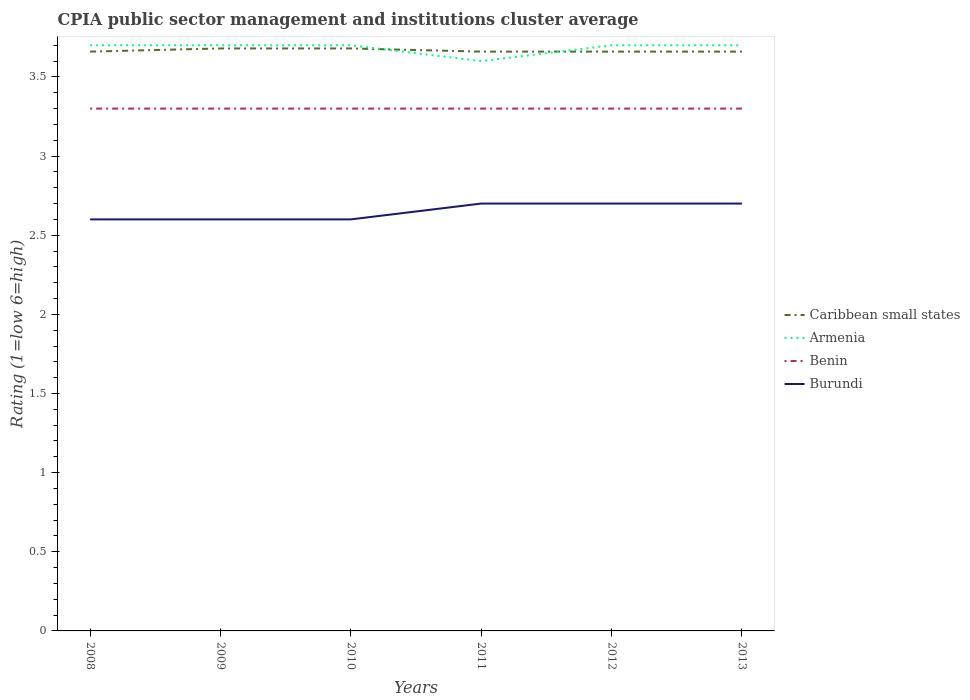How many different coloured lines are there?
Give a very brief answer. 4. Does the line corresponding to Armenia intersect with the line corresponding to Burundi?
Keep it short and to the point. No. What is the total CPIA rating in Armenia in the graph?
Offer a very short reply. 0. What is the difference between the highest and the second highest CPIA rating in Armenia?
Your response must be concise. 0.1. How many years are there in the graph?
Keep it short and to the point. 6. Are the values on the major ticks of Y-axis written in scientific E-notation?
Your answer should be compact. No. Does the graph contain any zero values?
Offer a terse response. No. Does the graph contain grids?
Provide a short and direct response. No. How are the legend labels stacked?
Make the answer very short. Vertical. What is the title of the graph?
Your response must be concise. CPIA public sector management and institutions cluster average. Does "Eritrea" appear as one of the legend labels in the graph?
Keep it short and to the point. No. What is the label or title of the X-axis?
Give a very brief answer. Years. What is the Rating (1=low 6=high) in Caribbean small states in 2008?
Your answer should be compact. 3.66. What is the Rating (1=low 6=high) of Burundi in 2008?
Make the answer very short. 2.6. What is the Rating (1=low 6=high) of Caribbean small states in 2009?
Your answer should be compact. 3.68. What is the Rating (1=low 6=high) in Benin in 2009?
Your response must be concise. 3.3. What is the Rating (1=low 6=high) in Burundi in 2009?
Offer a very short reply. 2.6. What is the Rating (1=low 6=high) in Caribbean small states in 2010?
Your answer should be compact. 3.68. What is the Rating (1=low 6=high) of Benin in 2010?
Keep it short and to the point. 3.3. What is the Rating (1=low 6=high) in Caribbean small states in 2011?
Your answer should be compact. 3.66. What is the Rating (1=low 6=high) of Armenia in 2011?
Give a very brief answer. 3.6. What is the Rating (1=low 6=high) in Benin in 2011?
Make the answer very short. 3.3. What is the Rating (1=low 6=high) of Caribbean small states in 2012?
Keep it short and to the point. 3.66. What is the Rating (1=low 6=high) in Armenia in 2012?
Provide a succinct answer. 3.7. What is the Rating (1=low 6=high) in Caribbean small states in 2013?
Make the answer very short. 3.66. What is the Rating (1=low 6=high) in Armenia in 2013?
Make the answer very short. 3.7. What is the Rating (1=low 6=high) in Benin in 2013?
Ensure brevity in your answer.  3.3. Across all years, what is the maximum Rating (1=low 6=high) of Caribbean small states?
Make the answer very short. 3.68. Across all years, what is the maximum Rating (1=low 6=high) of Benin?
Keep it short and to the point. 3.3. Across all years, what is the minimum Rating (1=low 6=high) of Caribbean small states?
Your response must be concise. 3.66. Across all years, what is the minimum Rating (1=low 6=high) in Armenia?
Give a very brief answer. 3.6. Across all years, what is the minimum Rating (1=low 6=high) in Benin?
Your answer should be compact. 3.3. Across all years, what is the minimum Rating (1=low 6=high) in Burundi?
Give a very brief answer. 2.6. What is the total Rating (1=low 6=high) in Caribbean small states in the graph?
Your answer should be very brief. 22. What is the total Rating (1=low 6=high) in Armenia in the graph?
Keep it short and to the point. 22.1. What is the total Rating (1=low 6=high) in Benin in the graph?
Offer a terse response. 19.8. What is the total Rating (1=low 6=high) in Burundi in the graph?
Offer a very short reply. 15.9. What is the difference between the Rating (1=low 6=high) in Caribbean small states in 2008 and that in 2009?
Provide a short and direct response. -0.02. What is the difference between the Rating (1=low 6=high) of Armenia in 2008 and that in 2009?
Give a very brief answer. 0. What is the difference between the Rating (1=low 6=high) in Benin in 2008 and that in 2009?
Make the answer very short. 0. What is the difference between the Rating (1=low 6=high) in Burundi in 2008 and that in 2009?
Provide a succinct answer. 0. What is the difference between the Rating (1=low 6=high) of Caribbean small states in 2008 and that in 2010?
Provide a succinct answer. -0.02. What is the difference between the Rating (1=low 6=high) of Armenia in 2008 and that in 2010?
Give a very brief answer. 0. What is the difference between the Rating (1=low 6=high) in Caribbean small states in 2008 and that in 2012?
Your answer should be very brief. 0. What is the difference between the Rating (1=low 6=high) in Armenia in 2008 and that in 2012?
Make the answer very short. 0. What is the difference between the Rating (1=low 6=high) of Benin in 2008 and that in 2012?
Your answer should be very brief. 0. What is the difference between the Rating (1=low 6=high) of Caribbean small states in 2008 and that in 2013?
Your response must be concise. 0. What is the difference between the Rating (1=low 6=high) of Armenia in 2008 and that in 2013?
Keep it short and to the point. 0. What is the difference between the Rating (1=low 6=high) in Burundi in 2008 and that in 2013?
Give a very brief answer. -0.1. What is the difference between the Rating (1=low 6=high) in Burundi in 2009 and that in 2010?
Your answer should be compact. 0. What is the difference between the Rating (1=low 6=high) in Benin in 2009 and that in 2011?
Your response must be concise. 0. What is the difference between the Rating (1=low 6=high) in Burundi in 2009 and that in 2011?
Offer a terse response. -0.1. What is the difference between the Rating (1=low 6=high) of Armenia in 2009 and that in 2012?
Keep it short and to the point. 0. What is the difference between the Rating (1=low 6=high) of Burundi in 2009 and that in 2012?
Your answer should be very brief. -0.1. What is the difference between the Rating (1=low 6=high) in Caribbean small states in 2009 and that in 2013?
Offer a very short reply. 0.02. What is the difference between the Rating (1=low 6=high) of Benin in 2009 and that in 2013?
Your answer should be very brief. 0. What is the difference between the Rating (1=low 6=high) of Caribbean small states in 2010 and that in 2011?
Provide a short and direct response. 0.02. What is the difference between the Rating (1=low 6=high) in Benin in 2010 and that in 2011?
Offer a very short reply. 0. What is the difference between the Rating (1=low 6=high) in Burundi in 2010 and that in 2011?
Give a very brief answer. -0.1. What is the difference between the Rating (1=low 6=high) of Benin in 2010 and that in 2012?
Ensure brevity in your answer.  0. What is the difference between the Rating (1=low 6=high) in Caribbean small states in 2010 and that in 2013?
Your answer should be compact. 0.02. What is the difference between the Rating (1=low 6=high) in Armenia in 2010 and that in 2013?
Keep it short and to the point. 0. What is the difference between the Rating (1=low 6=high) in Burundi in 2010 and that in 2013?
Offer a terse response. -0.1. What is the difference between the Rating (1=low 6=high) of Caribbean small states in 2011 and that in 2012?
Offer a terse response. 0. What is the difference between the Rating (1=low 6=high) of Armenia in 2011 and that in 2012?
Offer a terse response. -0.1. What is the difference between the Rating (1=low 6=high) of Benin in 2011 and that in 2012?
Your answer should be compact. 0. What is the difference between the Rating (1=low 6=high) in Caribbean small states in 2011 and that in 2013?
Offer a very short reply. 0. What is the difference between the Rating (1=low 6=high) in Armenia in 2011 and that in 2013?
Your answer should be compact. -0.1. What is the difference between the Rating (1=low 6=high) of Benin in 2011 and that in 2013?
Your answer should be very brief. 0. What is the difference between the Rating (1=low 6=high) of Burundi in 2011 and that in 2013?
Offer a terse response. 0. What is the difference between the Rating (1=low 6=high) of Burundi in 2012 and that in 2013?
Make the answer very short. 0. What is the difference between the Rating (1=low 6=high) of Caribbean small states in 2008 and the Rating (1=low 6=high) of Armenia in 2009?
Offer a very short reply. -0.04. What is the difference between the Rating (1=low 6=high) in Caribbean small states in 2008 and the Rating (1=low 6=high) in Benin in 2009?
Offer a very short reply. 0.36. What is the difference between the Rating (1=low 6=high) of Caribbean small states in 2008 and the Rating (1=low 6=high) of Burundi in 2009?
Keep it short and to the point. 1.06. What is the difference between the Rating (1=low 6=high) of Armenia in 2008 and the Rating (1=low 6=high) of Benin in 2009?
Your answer should be compact. 0.4. What is the difference between the Rating (1=low 6=high) of Armenia in 2008 and the Rating (1=low 6=high) of Burundi in 2009?
Offer a terse response. 1.1. What is the difference between the Rating (1=low 6=high) in Caribbean small states in 2008 and the Rating (1=low 6=high) in Armenia in 2010?
Your answer should be compact. -0.04. What is the difference between the Rating (1=low 6=high) in Caribbean small states in 2008 and the Rating (1=low 6=high) in Benin in 2010?
Your answer should be very brief. 0.36. What is the difference between the Rating (1=low 6=high) in Caribbean small states in 2008 and the Rating (1=low 6=high) in Burundi in 2010?
Provide a short and direct response. 1.06. What is the difference between the Rating (1=low 6=high) of Armenia in 2008 and the Rating (1=low 6=high) of Burundi in 2010?
Provide a short and direct response. 1.1. What is the difference between the Rating (1=low 6=high) of Benin in 2008 and the Rating (1=low 6=high) of Burundi in 2010?
Offer a terse response. 0.7. What is the difference between the Rating (1=low 6=high) of Caribbean small states in 2008 and the Rating (1=low 6=high) of Benin in 2011?
Give a very brief answer. 0.36. What is the difference between the Rating (1=low 6=high) of Armenia in 2008 and the Rating (1=low 6=high) of Benin in 2011?
Give a very brief answer. 0.4. What is the difference between the Rating (1=low 6=high) of Armenia in 2008 and the Rating (1=low 6=high) of Burundi in 2011?
Your response must be concise. 1. What is the difference between the Rating (1=low 6=high) of Benin in 2008 and the Rating (1=low 6=high) of Burundi in 2011?
Ensure brevity in your answer.  0.6. What is the difference between the Rating (1=low 6=high) of Caribbean small states in 2008 and the Rating (1=low 6=high) of Armenia in 2012?
Provide a succinct answer. -0.04. What is the difference between the Rating (1=low 6=high) of Caribbean small states in 2008 and the Rating (1=low 6=high) of Benin in 2012?
Give a very brief answer. 0.36. What is the difference between the Rating (1=low 6=high) of Benin in 2008 and the Rating (1=low 6=high) of Burundi in 2012?
Offer a very short reply. 0.6. What is the difference between the Rating (1=low 6=high) in Caribbean small states in 2008 and the Rating (1=low 6=high) in Armenia in 2013?
Make the answer very short. -0.04. What is the difference between the Rating (1=low 6=high) in Caribbean small states in 2008 and the Rating (1=low 6=high) in Benin in 2013?
Provide a succinct answer. 0.36. What is the difference between the Rating (1=low 6=high) of Armenia in 2008 and the Rating (1=low 6=high) of Benin in 2013?
Offer a terse response. 0.4. What is the difference between the Rating (1=low 6=high) in Armenia in 2008 and the Rating (1=low 6=high) in Burundi in 2013?
Offer a very short reply. 1. What is the difference between the Rating (1=low 6=high) of Caribbean small states in 2009 and the Rating (1=low 6=high) of Armenia in 2010?
Offer a terse response. -0.02. What is the difference between the Rating (1=low 6=high) of Caribbean small states in 2009 and the Rating (1=low 6=high) of Benin in 2010?
Keep it short and to the point. 0.38. What is the difference between the Rating (1=low 6=high) in Caribbean small states in 2009 and the Rating (1=low 6=high) in Burundi in 2010?
Give a very brief answer. 1.08. What is the difference between the Rating (1=low 6=high) of Armenia in 2009 and the Rating (1=low 6=high) of Benin in 2010?
Keep it short and to the point. 0.4. What is the difference between the Rating (1=low 6=high) in Armenia in 2009 and the Rating (1=low 6=high) in Burundi in 2010?
Make the answer very short. 1.1. What is the difference between the Rating (1=low 6=high) of Benin in 2009 and the Rating (1=low 6=high) of Burundi in 2010?
Ensure brevity in your answer.  0.7. What is the difference between the Rating (1=low 6=high) of Caribbean small states in 2009 and the Rating (1=low 6=high) of Benin in 2011?
Provide a succinct answer. 0.38. What is the difference between the Rating (1=low 6=high) of Caribbean small states in 2009 and the Rating (1=low 6=high) of Burundi in 2011?
Provide a short and direct response. 0.98. What is the difference between the Rating (1=low 6=high) of Armenia in 2009 and the Rating (1=low 6=high) of Benin in 2011?
Offer a very short reply. 0.4. What is the difference between the Rating (1=low 6=high) in Armenia in 2009 and the Rating (1=low 6=high) in Burundi in 2011?
Offer a terse response. 1. What is the difference between the Rating (1=low 6=high) of Caribbean small states in 2009 and the Rating (1=low 6=high) of Armenia in 2012?
Provide a succinct answer. -0.02. What is the difference between the Rating (1=low 6=high) in Caribbean small states in 2009 and the Rating (1=low 6=high) in Benin in 2012?
Keep it short and to the point. 0.38. What is the difference between the Rating (1=low 6=high) in Armenia in 2009 and the Rating (1=low 6=high) in Benin in 2012?
Ensure brevity in your answer.  0.4. What is the difference between the Rating (1=low 6=high) of Armenia in 2009 and the Rating (1=low 6=high) of Burundi in 2012?
Provide a succinct answer. 1. What is the difference between the Rating (1=low 6=high) in Caribbean small states in 2009 and the Rating (1=low 6=high) in Armenia in 2013?
Provide a short and direct response. -0.02. What is the difference between the Rating (1=low 6=high) in Caribbean small states in 2009 and the Rating (1=low 6=high) in Benin in 2013?
Keep it short and to the point. 0.38. What is the difference between the Rating (1=low 6=high) in Caribbean small states in 2009 and the Rating (1=low 6=high) in Burundi in 2013?
Ensure brevity in your answer.  0.98. What is the difference between the Rating (1=low 6=high) of Armenia in 2009 and the Rating (1=low 6=high) of Burundi in 2013?
Provide a succinct answer. 1. What is the difference between the Rating (1=low 6=high) of Caribbean small states in 2010 and the Rating (1=low 6=high) of Armenia in 2011?
Offer a terse response. 0.08. What is the difference between the Rating (1=low 6=high) of Caribbean small states in 2010 and the Rating (1=low 6=high) of Benin in 2011?
Your response must be concise. 0.38. What is the difference between the Rating (1=low 6=high) in Caribbean small states in 2010 and the Rating (1=low 6=high) in Burundi in 2011?
Offer a terse response. 0.98. What is the difference between the Rating (1=low 6=high) in Benin in 2010 and the Rating (1=low 6=high) in Burundi in 2011?
Offer a very short reply. 0.6. What is the difference between the Rating (1=low 6=high) in Caribbean small states in 2010 and the Rating (1=low 6=high) in Armenia in 2012?
Your response must be concise. -0.02. What is the difference between the Rating (1=low 6=high) of Caribbean small states in 2010 and the Rating (1=low 6=high) of Benin in 2012?
Provide a succinct answer. 0.38. What is the difference between the Rating (1=low 6=high) of Armenia in 2010 and the Rating (1=low 6=high) of Burundi in 2012?
Your response must be concise. 1. What is the difference between the Rating (1=low 6=high) of Benin in 2010 and the Rating (1=low 6=high) of Burundi in 2012?
Ensure brevity in your answer.  0.6. What is the difference between the Rating (1=low 6=high) in Caribbean small states in 2010 and the Rating (1=low 6=high) in Armenia in 2013?
Give a very brief answer. -0.02. What is the difference between the Rating (1=low 6=high) in Caribbean small states in 2010 and the Rating (1=low 6=high) in Benin in 2013?
Offer a very short reply. 0.38. What is the difference between the Rating (1=low 6=high) in Caribbean small states in 2010 and the Rating (1=low 6=high) in Burundi in 2013?
Your answer should be very brief. 0.98. What is the difference between the Rating (1=low 6=high) in Caribbean small states in 2011 and the Rating (1=low 6=high) in Armenia in 2012?
Offer a terse response. -0.04. What is the difference between the Rating (1=low 6=high) of Caribbean small states in 2011 and the Rating (1=low 6=high) of Benin in 2012?
Ensure brevity in your answer.  0.36. What is the difference between the Rating (1=low 6=high) of Caribbean small states in 2011 and the Rating (1=low 6=high) of Burundi in 2012?
Keep it short and to the point. 0.96. What is the difference between the Rating (1=low 6=high) in Armenia in 2011 and the Rating (1=low 6=high) in Burundi in 2012?
Give a very brief answer. 0.9. What is the difference between the Rating (1=low 6=high) of Caribbean small states in 2011 and the Rating (1=low 6=high) of Armenia in 2013?
Your answer should be compact. -0.04. What is the difference between the Rating (1=low 6=high) of Caribbean small states in 2011 and the Rating (1=low 6=high) of Benin in 2013?
Your answer should be very brief. 0.36. What is the difference between the Rating (1=low 6=high) in Caribbean small states in 2011 and the Rating (1=low 6=high) in Burundi in 2013?
Your answer should be very brief. 0.96. What is the difference between the Rating (1=low 6=high) of Caribbean small states in 2012 and the Rating (1=low 6=high) of Armenia in 2013?
Ensure brevity in your answer.  -0.04. What is the difference between the Rating (1=low 6=high) in Caribbean small states in 2012 and the Rating (1=low 6=high) in Benin in 2013?
Your response must be concise. 0.36. What is the difference between the Rating (1=low 6=high) of Caribbean small states in 2012 and the Rating (1=low 6=high) of Burundi in 2013?
Make the answer very short. 0.96. What is the difference between the Rating (1=low 6=high) of Armenia in 2012 and the Rating (1=low 6=high) of Benin in 2013?
Give a very brief answer. 0.4. What is the difference between the Rating (1=low 6=high) in Armenia in 2012 and the Rating (1=low 6=high) in Burundi in 2013?
Provide a succinct answer. 1. What is the difference between the Rating (1=low 6=high) of Benin in 2012 and the Rating (1=low 6=high) of Burundi in 2013?
Your response must be concise. 0.6. What is the average Rating (1=low 6=high) of Caribbean small states per year?
Your answer should be very brief. 3.67. What is the average Rating (1=low 6=high) of Armenia per year?
Ensure brevity in your answer.  3.68. What is the average Rating (1=low 6=high) of Burundi per year?
Give a very brief answer. 2.65. In the year 2008, what is the difference between the Rating (1=low 6=high) of Caribbean small states and Rating (1=low 6=high) of Armenia?
Offer a terse response. -0.04. In the year 2008, what is the difference between the Rating (1=low 6=high) in Caribbean small states and Rating (1=low 6=high) in Benin?
Make the answer very short. 0.36. In the year 2008, what is the difference between the Rating (1=low 6=high) of Caribbean small states and Rating (1=low 6=high) of Burundi?
Offer a terse response. 1.06. In the year 2008, what is the difference between the Rating (1=low 6=high) in Armenia and Rating (1=low 6=high) in Benin?
Your answer should be very brief. 0.4. In the year 2008, what is the difference between the Rating (1=low 6=high) in Armenia and Rating (1=low 6=high) in Burundi?
Your answer should be very brief. 1.1. In the year 2008, what is the difference between the Rating (1=low 6=high) of Benin and Rating (1=low 6=high) of Burundi?
Offer a very short reply. 0.7. In the year 2009, what is the difference between the Rating (1=low 6=high) in Caribbean small states and Rating (1=low 6=high) in Armenia?
Provide a succinct answer. -0.02. In the year 2009, what is the difference between the Rating (1=low 6=high) in Caribbean small states and Rating (1=low 6=high) in Benin?
Keep it short and to the point. 0.38. In the year 2009, what is the difference between the Rating (1=low 6=high) of Caribbean small states and Rating (1=low 6=high) of Burundi?
Keep it short and to the point. 1.08. In the year 2009, what is the difference between the Rating (1=low 6=high) in Armenia and Rating (1=low 6=high) in Benin?
Make the answer very short. 0.4. In the year 2010, what is the difference between the Rating (1=low 6=high) in Caribbean small states and Rating (1=low 6=high) in Armenia?
Keep it short and to the point. -0.02. In the year 2010, what is the difference between the Rating (1=low 6=high) in Caribbean small states and Rating (1=low 6=high) in Benin?
Offer a very short reply. 0.38. In the year 2010, what is the difference between the Rating (1=low 6=high) in Caribbean small states and Rating (1=low 6=high) in Burundi?
Offer a very short reply. 1.08. In the year 2010, what is the difference between the Rating (1=low 6=high) in Armenia and Rating (1=low 6=high) in Burundi?
Give a very brief answer. 1.1. In the year 2010, what is the difference between the Rating (1=low 6=high) of Benin and Rating (1=low 6=high) of Burundi?
Make the answer very short. 0.7. In the year 2011, what is the difference between the Rating (1=low 6=high) of Caribbean small states and Rating (1=low 6=high) of Armenia?
Your answer should be compact. 0.06. In the year 2011, what is the difference between the Rating (1=low 6=high) in Caribbean small states and Rating (1=low 6=high) in Benin?
Offer a terse response. 0.36. In the year 2011, what is the difference between the Rating (1=low 6=high) in Benin and Rating (1=low 6=high) in Burundi?
Your response must be concise. 0.6. In the year 2012, what is the difference between the Rating (1=low 6=high) in Caribbean small states and Rating (1=low 6=high) in Armenia?
Ensure brevity in your answer.  -0.04. In the year 2012, what is the difference between the Rating (1=low 6=high) of Caribbean small states and Rating (1=low 6=high) of Benin?
Your answer should be very brief. 0.36. In the year 2012, what is the difference between the Rating (1=low 6=high) in Armenia and Rating (1=low 6=high) in Benin?
Provide a succinct answer. 0.4. In the year 2012, what is the difference between the Rating (1=low 6=high) of Armenia and Rating (1=low 6=high) of Burundi?
Provide a short and direct response. 1. In the year 2012, what is the difference between the Rating (1=low 6=high) of Benin and Rating (1=low 6=high) of Burundi?
Offer a terse response. 0.6. In the year 2013, what is the difference between the Rating (1=low 6=high) of Caribbean small states and Rating (1=low 6=high) of Armenia?
Provide a succinct answer. -0.04. In the year 2013, what is the difference between the Rating (1=low 6=high) in Caribbean small states and Rating (1=low 6=high) in Benin?
Provide a short and direct response. 0.36. What is the ratio of the Rating (1=low 6=high) of Caribbean small states in 2008 to that in 2009?
Provide a succinct answer. 0.99. What is the ratio of the Rating (1=low 6=high) in Armenia in 2008 to that in 2009?
Ensure brevity in your answer.  1. What is the ratio of the Rating (1=low 6=high) in Benin in 2008 to that in 2009?
Your response must be concise. 1. What is the ratio of the Rating (1=low 6=high) of Caribbean small states in 2008 to that in 2010?
Provide a short and direct response. 0.99. What is the ratio of the Rating (1=low 6=high) in Armenia in 2008 to that in 2011?
Make the answer very short. 1.03. What is the ratio of the Rating (1=low 6=high) in Benin in 2008 to that in 2011?
Your answer should be compact. 1. What is the ratio of the Rating (1=low 6=high) in Burundi in 2008 to that in 2011?
Ensure brevity in your answer.  0.96. What is the ratio of the Rating (1=low 6=high) in Burundi in 2008 to that in 2012?
Your answer should be very brief. 0.96. What is the ratio of the Rating (1=low 6=high) of Caribbean small states in 2008 to that in 2013?
Offer a very short reply. 1. What is the ratio of the Rating (1=low 6=high) in Armenia in 2008 to that in 2013?
Your answer should be compact. 1. What is the ratio of the Rating (1=low 6=high) in Benin in 2008 to that in 2013?
Your response must be concise. 1. What is the ratio of the Rating (1=low 6=high) in Armenia in 2009 to that in 2010?
Your response must be concise. 1. What is the ratio of the Rating (1=low 6=high) in Benin in 2009 to that in 2010?
Offer a very short reply. 1. What is the ratio of the Rating (1=low 6=high) of Armenia in 2009 to that in 2011?
Give a very brief answer. 1.03. What is the ratio of the Rating (1=low 6=high) in Benin in 2009 to that in 2011?
Make the answer very short. 1. What is the ratio of the Rating (1=low 6=high) in Caribbean small states in 2009 to that in 2012?
Give a very brief answer. 1.01. What is the ratio of the Rating (1=low 6=high) of Armenia in 2009 to that in 2012?
Ensure brevity in your answer.  1. What is the ratio of the Rating (1=low 6=high) in Benin in 2009 to that in 2012?
Offer a terse response. 1. What is the ratio of the Rating (1=low 6=high) of Burundi in 2009 to that in 2012?
Ensure brevity in your answer.  0.96. What is the ratio of the Rating (1=low 6=high) of Caribbean small states in 2009 to that in 2013?
Ensure brevity in your answer.  1.01. What is the ratio of the Rating (1=low 6=high) of Armenia in 2009 to that in 2013?
Ensure brevity in your answer.  1. What is the ratio of the Rating (1=low 6=high) of Benin in 2009 to that in 2013?
Offer a very short reply. 1. What is the ratio of the Rating (1=low 6=high) of Caribbean small states in 2010 to that in 2011?
Offer a terse response. 1.01. What is the ratio of the Rating (1=low 6=high) of Armenia in 2010 to that in 2011?
Give a very brief answer. 1.03. What is the ratio of the Rating (1=low 6=high) of Caribbean small states in 2010 to that in 2012?
Keep it short and to the point. 1.01. What is the ratio of the Rating (1=low 6=high) in Benin in 2010 to that in 2012?
Your answer should be very brief. 1. What is the ratio of the Rating (1=low 6=high) in Burundi in 2010 to that in 2012?
Your answer should be compact. 0.96. What is the ratio of the Rating (1=low 6=high) of Caribbean small states in 2010 to that in 2013?
Ensure brevity in your answer.  1.01. What is the ratio of the Rating (1=low 6=high) of Armenia in 2010 to that in 2013?
Ensure brevity in your answer.  1. What is the ratio of the Rating (1=low 6=high) of Caribbean small states in 2011 to that in 2012?
Provide a short and direct response. 1. What is the ratio of the Rating (1=low 6=high) of Benin in 2011 to that in 2012?
Give a very brief answer. 1. What is the ratio of the Rating (1=low 6=high) of Burundi in 2011 to that in 2012?
Provide a succinct answer. 1. What is the ratio of the Rating (1=low 6=high) in Burundi in 2011 to that in 2013?
Offer a terse response. 1. What is the ratio of the Rating (1=low 6=high) of Caribbean small states in 2012 to that in 2013?
Your answer should be compact. 1. What is the ratio of the Rating (1=low 6=high) of Benin in 2012 to that in 2013?
Your response must be concise. 1. What is the difference between the highest and the second highest Rating (1=low 6=high) in Armenia?
Your answer should be very brief. 0. What is the difference between the highest and the second highest Rating (1=low 6=high) in Benin?
Offer a very short reply. 0. What is the difference between the highest and the second highest Rating (1=low 6=high) of Burundi?
Your response must be concise. 0. What is the difference between the highest and the lowest Rating (1=low 6=high) in Caribbean small states?
Give a very brief answer. 0.02. What is the difference between the highest and the lowest Rating (1=low 6=high) in Benin?
Give a very brief answer. 0. What is the difference between the highest and the lowest Rating (1=low 6=high) of Burundi?
Make the answer very short. 0.1. 